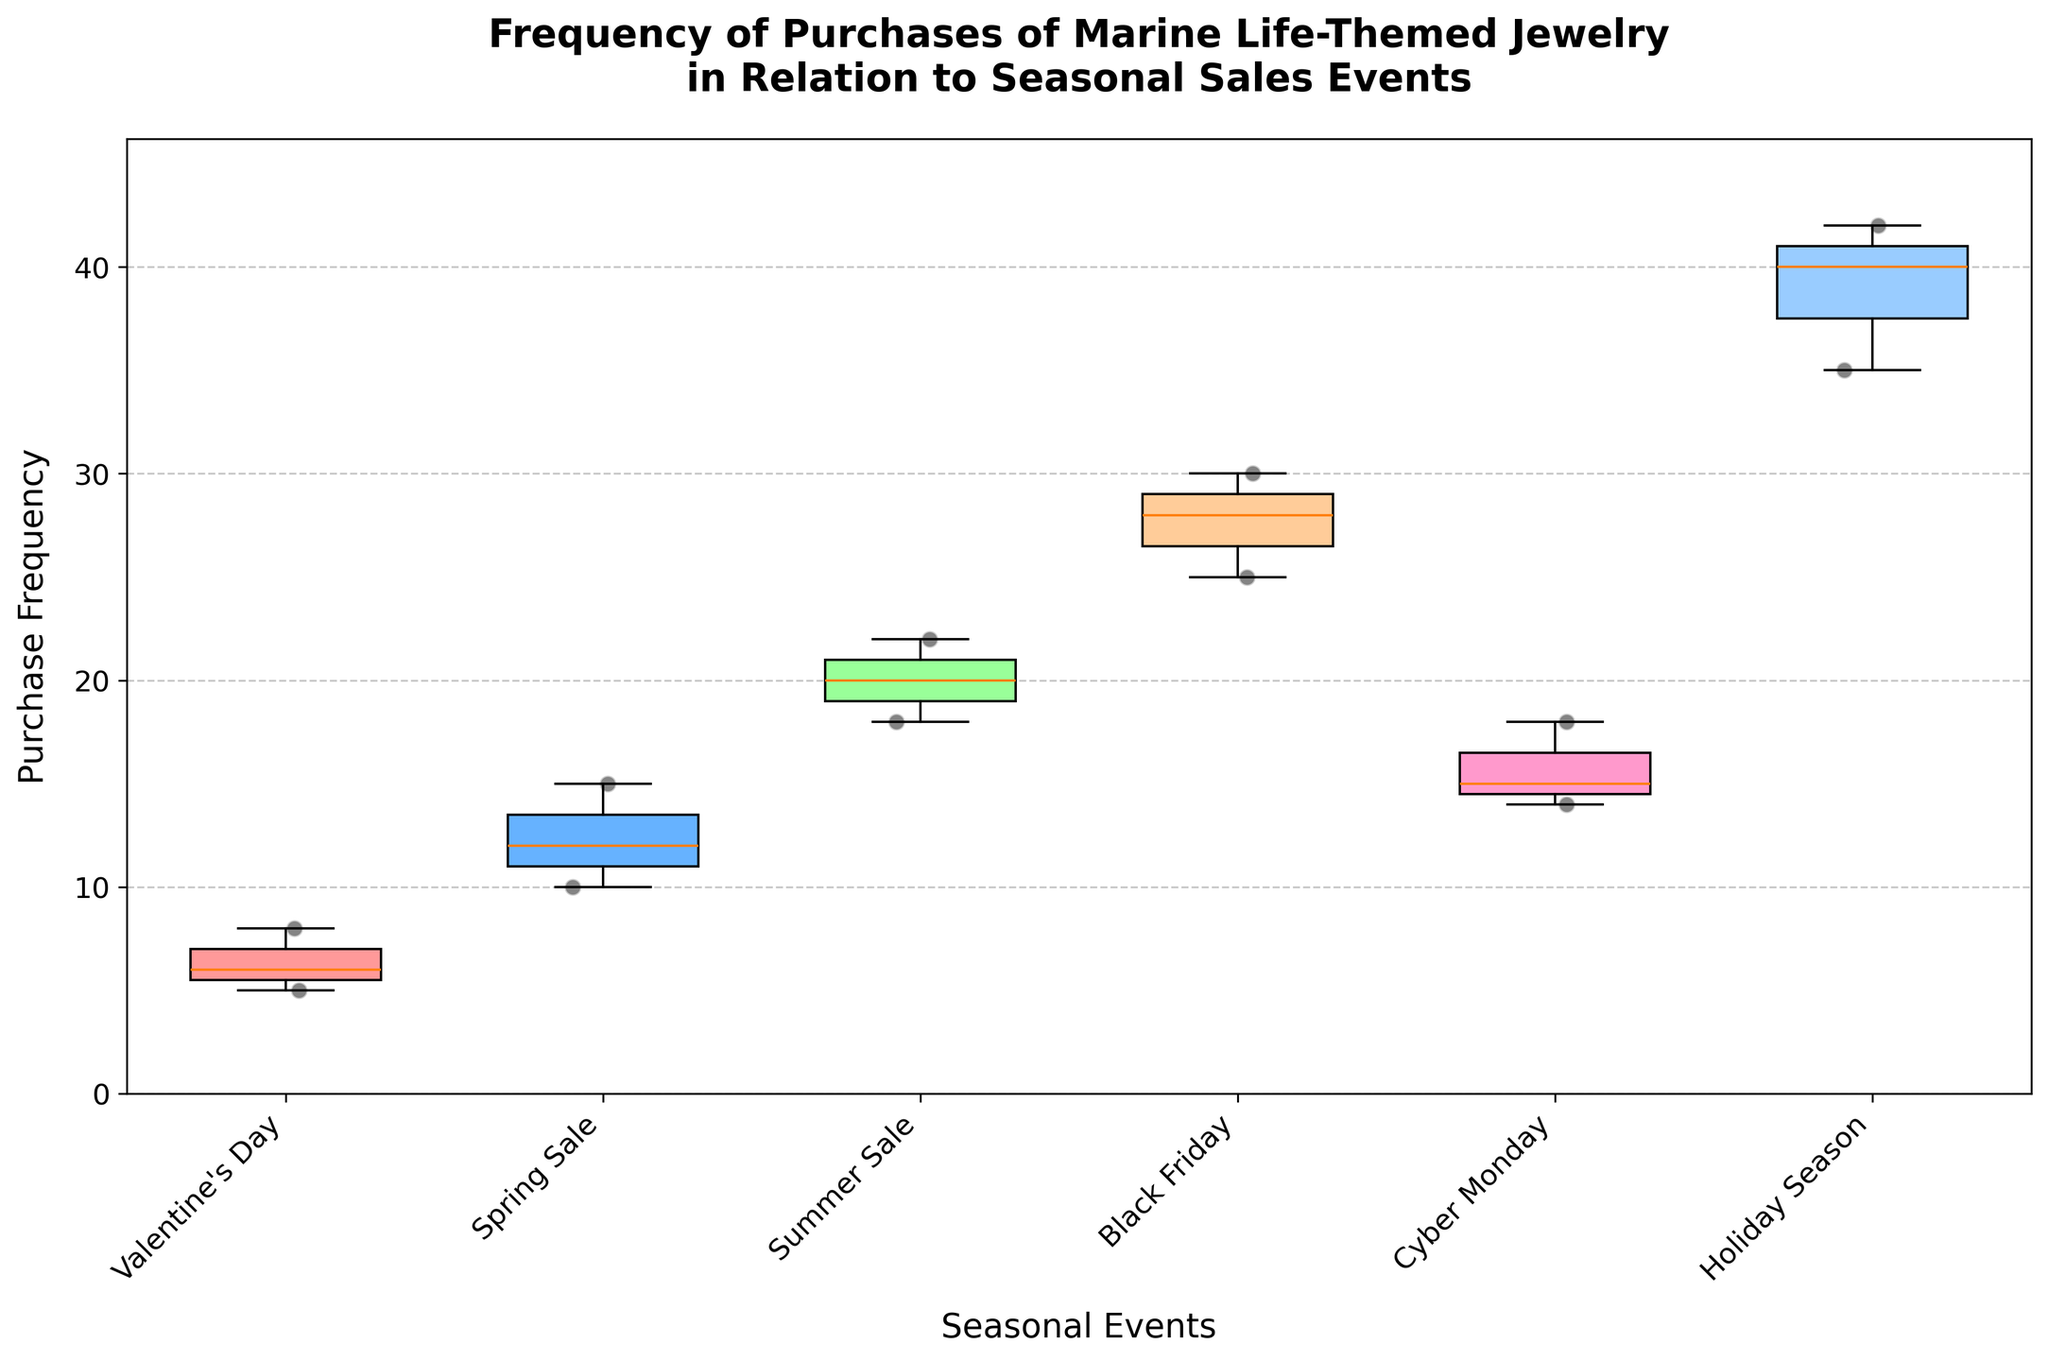What's the title of the plot? The title of the plot is displayed prominently at the top.
Answer: Frequency of Purchases of Marine Life-Themed Jewelry in Relation to Seasonal Sales Events Which seasonal event has the highest purchase frequency? By examining the plot, we see that the Holiday Season has the highest purchase frequency values, with points reaching up to 42.
Answer: Holiday Season What is the range of purchase frequencies for the Spring Sale event? For Spring Sale, the box plot shows data points ranging from 10 to 15 without any outliers.
Answer: 10 to 15 How does the median purchase frequency for Summer Sale compare to that of Cyber Monday? The median is represented by the line inside each box. For Summer Sale, the median appears to be around 20, whereas for Cyber Monday, it’s around 15.
Answer: Higher for Summer Sale Identify an event with no outliers. Outliers are represented by points outside the whiskers of the box plot. Upon inspection, Valentine's Day has no outliers.
Answer: Valentine's Day What is the approximate difference in median purchase frequency between Black Friday and Valentine's Day? The median for Black Friday is around 28 and for Valentine's Day is around 6. Subtract the smaller value from the larger value for the difference.
Answer: Approximately 22 Which seasonal event has the most variability in purchase frequencies? Variability can be assessed by the length of the box and whiskers. Holiday Season covers a wide range from around 35 to 42, indicating high variability.
Answer: Holiday Season How are scatter points adding information to the standard box plot? The scatter points reveal the actual distribution and density of individual data points, giving more granular insights into the spread of purchase frequencies for each event.
Answer: Shows individual data points What's the interquartile range (IQR) for Black Friday purchases? IQR is calculated by subtracting the first quartile (approx. 25) from the third quartile (approx. 30) in the Black Friday box plot.
Answer: Approximately 5 Which event demonstrates the largest range between the maximum and minimum purchase frequencies? The range is determined by the difference between the highest and lowest points. Holiday Season spans from 35 to 42, a range of 7, the largest observed in the figure.
Answer: Holiday Season 